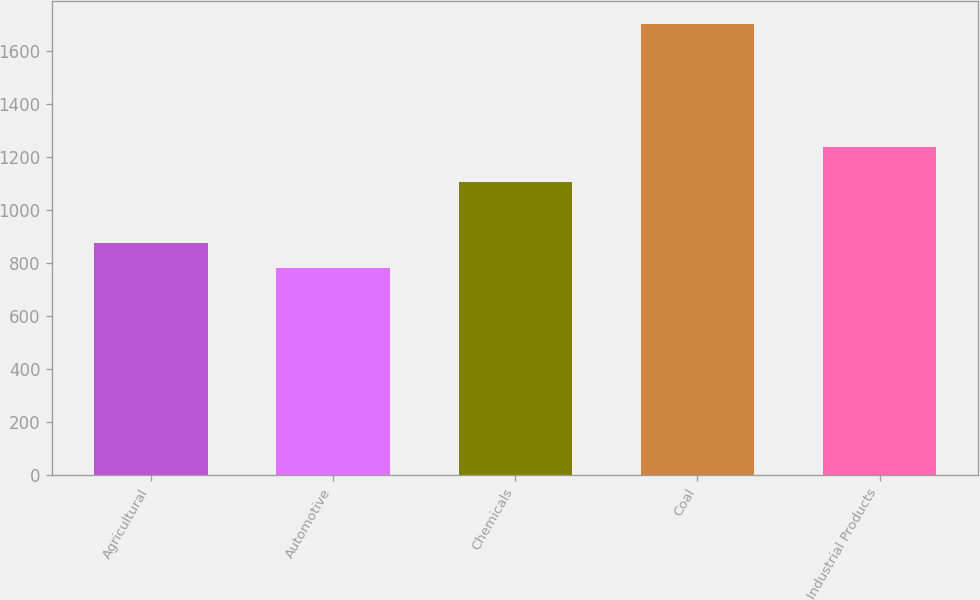Convert chart. <chart><loc_0><loc_0><loc_500><loc_500><bar_chart><fcel>Agricultural<fcel>Automotive<fcel>Chemicals<fcel>Coal<fcel>Industrial Products<nl><fcel>874<fcel>781<fcel>1103<fcel>1703<fcel>1236<nl></chart> 